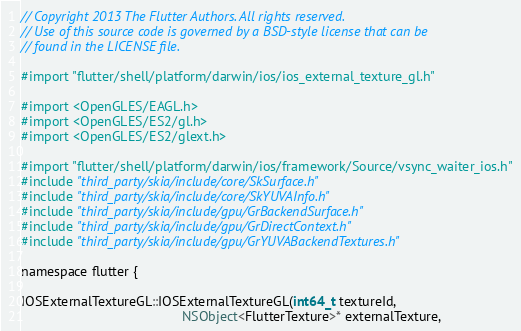<code> <loc_0><loc_0><loc_500><loc_500><_ObjectiveC_>// Copyright 2013 The Flutter Authors. All rights reserved.
// Use of this source code is governed by a BSD-style license that can be
// found in the LICENSE file.

#import "flutter/shell/platform/darwin/ios/ios_external_texture_gl.h"

#import <OpenGLES/EAGL.h>
#import <OpenGLES/ES2/gl.h>
#import <OpenGLES/ES2/glext.h>

#import "flutter/shell/platform/darwin/ios/framework/Source/vsync_waiter_ios.h"
#include "third_party/skia/include/core/SkSurface.h"
#include "third_party/skia/include/core/SkYUVAInfo.h"
#include "third_party/skia/include/gpu/GrBackendSurface.h"
#include "third_party/skia/include/gpu/GrDirectContext.h"
#include "third_party/skia/include/gpu/GrYUVABackendTextures.h"

namespace flutter {

IOSExternalTextureGL::IOSExternalTextureGL(int64_t textureId,
                                           NSObject<FlutterTexture>* externalTexture,</code> 